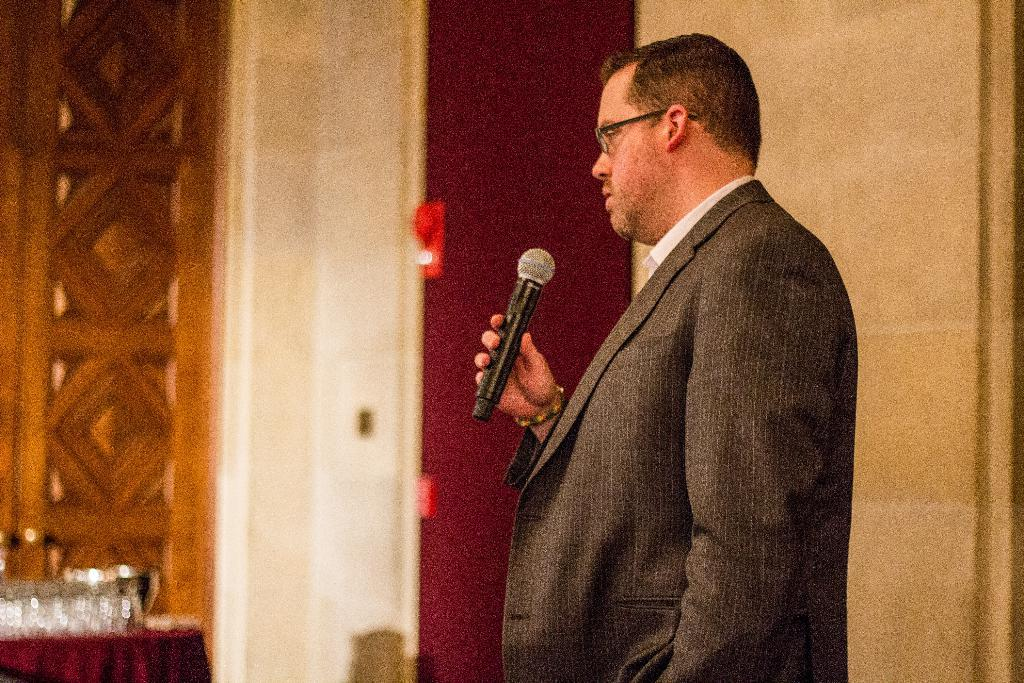Who is the person in the image? There is a man in the image. What can be seen on the man's face? The man is wearing spectacles. What is the man holding in his hand? The man is holding a microphone in his hand. What objects are on the table in the image? There are glasses on the table in the image. What can be seen in the background of the image? There is a wall visible in the image. How does the man's digestion process appear in the image? There is no indication of the man's digestion process in the image; it focuses on the man, his spectacles, the microphone, and the objects on the table. 